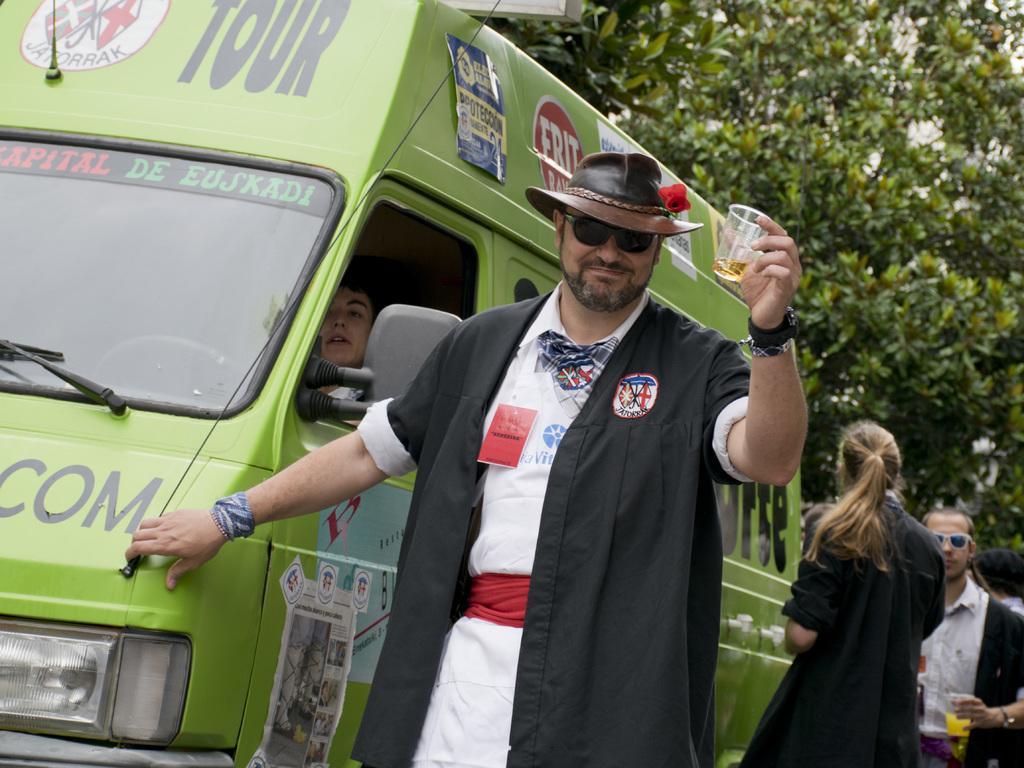Could you give a brief overview of what you see in this image? In this image in the center there is one person who is standing and he is holding a cup, in the cup there is some drink and in the background there is a vehicle. In the vehicle there is one person sitting, and on the right side there are some people who are holding glasses. And at the top of the image we could see some trees. 